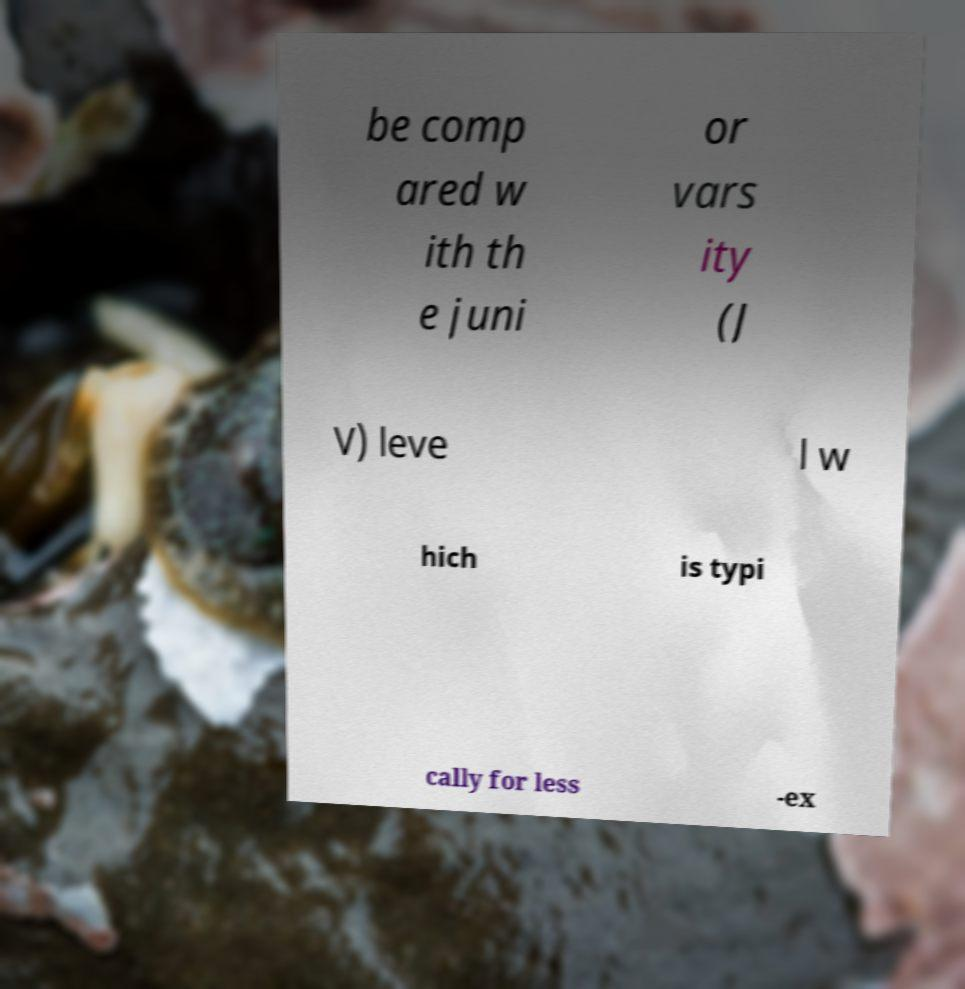Could you extract and type out the text from this image? be comp ared w ith th e juni or vars ity (J V) leve l w hich is typi cally for less -ex 